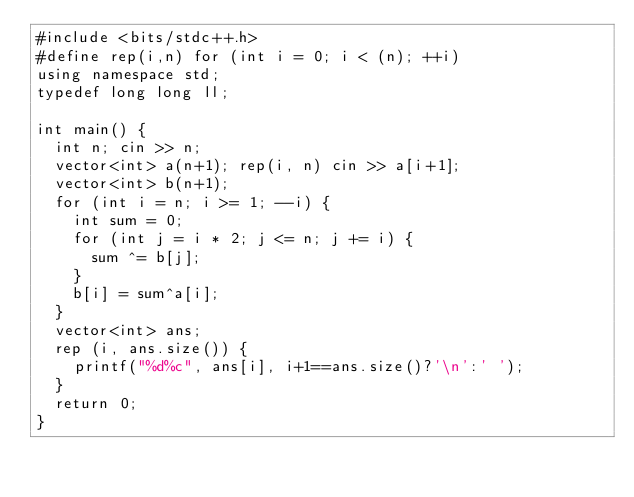<code> <loc_0><loc_0><loc_500><loc_500><_C++_>#include <bits/stdc++.h>
#define rep(i,n) for (int i = 0; i < (n); ++i)
using namespace std;
typedef long long ll;

int main() {
  int n; cin >> n;
  vector<int> a(n+1); rep(i, n) cin >> a[i+1];
  vector<int> b(n+1);
  for (int i = n; i >= 1; --i) {
    int sum = 0;
    for (int j = i * 2; j <= n; j += i) {
      sum ^= b[j];
    }
    b[i] = sum^a[i];
  }
  vector<int> ans;
  rep (i, ans.size()) {
    printf("%d%c", ans[i], i+1==ans.size()?'\n':' ');
  }
  return 0;
}
</code> 